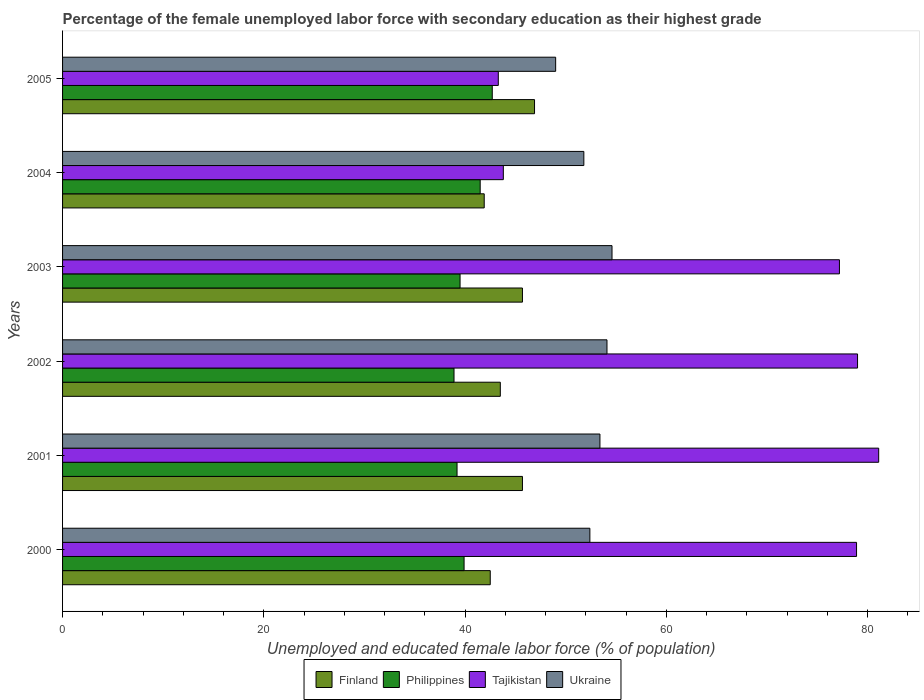How many groups of bars are there?
Provide a short and direct response. 6. Are the number of bars on each tick of the Y-axis equal?
Provide a short and direct response. Yes. How many bars are there on the 2nd tick from the top?
Keep it short and to the point. 4. In how many cases, is the number of bars for a given year not equal to the number of legend labels?
Your response must be concise. 0. What is the percentage of the unemployed female labor force with secondary education in Ukraine in 2003?
Ensure brevity in your answer.  54.6. Across all years, what is the maximum percentage of the unemployed female labor force with secondary education in Ukraine?
Offer a very short reply. 54.6. Across all years, what is the minimum percentage of the unemployed female labor force with secondary education in Finland?
Provide a short and direct response. 41.9. What is the total percentage of the unemployed female labor force with secondary education in Finland in the graph?
Your response must be concise. 266.2. What is the difference between the percentage of the unemployed female labor force with secondary education in Finland in 2002 and that in 2005?
Offer a terse response. -3.4. What is the difference between the percentage of the unemployed female labor force with secondary education in Tajikistan in 2000 and the percentage of the unemployed female labor force with secondary education in Philippines in 2003?
Offer a terse response. 39.4. What is the average percentage of the unemployed female labor force with secondary education in Finland per year?
Offer a terse response. 44.37. In the year 2004, what is the difference between the percentage of the unemployed female labor force with secondary education in Finland and percentage of the unemployed female labor force with secondary education in Philippines?
Your answer should be compact. 0.4. In how many years, is the percentage of the unemployed female labor force with secondary education in Ukraine greater than 12 %?
Give a very brief answer. 6. What is the ratio of the percentage of the unemployed female labor force with secondary education in Ukraine in 2003 to that in 2005?
Ensure brevity in your answer.  1.11. What is the difference between the highest and the second highest percentage of the unemployed female labor force with secondary education in Finland?
Give a very brief answer. 1.2. What is the difference between the highest and the lowest percentage of the unemployed female labor force with secondary education in Finland?
Offer a very short reply. 5. What does the 3rd bar from the top in 2000 represents?
Your answer should be compact. Philippines. How many bars are there?
Your response must be concise. 24. How many years are there in the graph?
Offer a terse response. 6. Are the values on the major ticks of X-axis written in scientific E-notation?
Offer a terse response. No. Does the graph contain grids?
Make the answer very short. No. Where does the legend appear in the graph?
Offer a terse response. Bottom center. How many legend labels are there?
Your answer should be compact. 4. How are the legend labels stacked?
Give a very brief answer. Horizontal. What is the title of the graph?
Provide a succinct answer. Percentage of the female unemployed labor force with secondary education as their highest grade. Does "Serbia" appear as one of the legend labels in the graph?
Offer a very short reply. No. What is the label or title of the X-axis?
Make the answer very short. Unemployed and educated female labor force (% of population). What is the label or title of the Y-axis?
Your answer should be compact. Years. What is the Unemployed and educated female labor force (% of population) of Finland in 2000?
Keep it short and to the point. 42.5. What is the Unemployed and educated female labor force (% of population) in Philippines in 2000?
Your answer should be very brief. 39.9. What is the Unemployed and educated female labor force (% of population) in Tajikistan in 2000?
Offer a terse response. 78.9. What is the Unemployed and educated female labor force (% of population) of Ukraine in 2000?
Make the answer very short. 52.4. What is the Unemployed and educated female labor force (% of population) in Finland in 2001?
Keep it short and to the point. 45.7. What is the Unemployed and educated female labor force (% of population) of Philippines in 2001?
Provide a succinct answer. 39.2. What is the Unemployed and educated female labor force (% of population) of Tajikistan in 2001?
Your answer should be very brief. 81.1. What is the Unemployed and educated female labor force (% of population) of Ukraine in 2001?
Provide a short and direct response. 53.4. What is the Unemployed and educated female labor force (% of population) in Finland in 2002?
Provide a succinct answer. 43.5. What is the Unemployed and educated female labor force (% of population) of Philippines in 2002?
Provide a succinct answer. 38.9. What is the Unemployed and educated female labor force (% of population) of Tajikistan in 2002?
Make the answer very short. 79. What is the Unemployed and educated female labor force (% of population) of Ukraine in 2002?
Offer a very short reply. 54.1. What is the Unemployed and educated female labor force (% of population) in Finland in 2003?
Your response must be concise. 45.7. What is the Unemployed and educated female labor force (% of population) of Philippines in 2003?
Offer a very short reply. 39.5. What is the Unemployed and educated female labor force (% of population) of Tajikistan in 2003?
Give a very brief answer. 77.2. What is the Unemployed and educated female labor force (% of population) of Ukraine in 2003?
Make the answer very short. 54.6. What is the Unemployed and educated female labor force (% of population) in Finland in 2004?
Your response must be concise. 41.9. What is the Unemployed and educated female labor force (% of population) in Philippines in 2004?
Your answer should be compact. 41.5. What is the Unemployed and educated female labor force (% of population) in Tajikistan in 2004?
Keep it short and to the point. 43.8. What is the Unemployed and educated female labor force (% of population) of Ukraine in 2004?
Ensure brevity in your answer.  51.8. What is the Unemployed and educated female labor force (% of population) of Finland in 2005?
Offer a very short reply. 46.9. What is the Unemployed and educated female labor force (% of population) of Philippines in 2005?
Provide a short and direct response. 42.7. What is the Unemployed and educated female labor force (% of population) of Tajikistan in 2005?
Your answer should be compact. 43.3. What is the Unemployed and educated female labor force (% of population) in Ukraine in 2005?
Your answer should be compact. 49. Across all years, what is the maximum Unemployed and educated female labor force (% of population) in Finland?
Your response must be concise. 46.9. Across all years, what is the maximum Unemployed and educated female labor force (% of population) of Philippines?
Offer a terse response. 42.7. Across all years, what is the maximum Unemployed and educated female labor force (% of population) in Tajikistan?
Give a very brief answer. 81.1. Across all years, what is the maximum Unemployed and educated female labor force (% of population) in Ukraine?
Provide a succinct answer. 54.6. Across all years, what is the minimum Unemployed and educated female labor force (% of population) of Finland?
Your answer should be very brief. 41.9. Across all years, what is the minimum Unemployed and educated female labor force (% of population) of Philippines?
Provide a short and direct response. 38.9. Across all years, what is the minimum Unemployed and educated female labor force (% of population) in Tajikistan?
Offer a terse response. 43.3. What is the total Unemployed and educated female labor force (% of population) of Finland in the graph?
Keep it short and to the point. 266.2. What is the total Unemployed and educated female labor force (% of population) in Philippines in the graph?
Offer a terse response. 241.7. What is the total Unemployed and educated female labor force (% of population) in Tajikistan in the graph?
Ensure brevity in your answer.  403.3. What is the total Unemployed and educated female labor force (% of population) in Ukraine in the graph?
Your answer should be compact. 315.3. What is the difference between the Unemployed and educated female labor force (% of population) in Finland in 2000 and that in 2001?
Your answer should be compact. -3.2. What is the difference between the Unemployed and educated female labor force (% of population) in Tajikistan in 2000 and that in 2001?
Offer a very short reply. -2.2. What is the difference between the Unemployed and educated female labor force (% of population) of Ukraine in 2000 and that in 2001?
Make the answer very short. -1. What is the difference between the Unemployed and educated female labor force (% of population) in Finland in 2000 and that in 2002?
Offer a very short reply. -1. What is the difference between the Unemployed and educated female labor force (% of population) of Tajikistan in 2000 and that in 2003?
Make the answer very short. 1.7. What is the difference between the Unemployed and educated female labor force (% of population) of Ukraine in 2000 and that in 2003?
Keep it short and to the point. -2.2. What is the difference between the Unemployed and educated female labor force (% of population) of Tajikistan in 2000 and that in 2004?
Make the answer very short. 35.1. What is the difference between the Unemployed and educated female labor force (% of population) in Finland in 2000 and that in 2005?
Offer a terse response. -4.4. What is the difference between the Unemployed and educated female labor force (% of population) in Philippines in 2000 and that in 2005?
Ensure brevity in your answer.  -2.8. What is the difference between the Unemployed and educated female labor force (% of population) in Tajikistan in 2000 and that in 2005?
Offer a very short reply. 35.6. What is the difference between the Unemployed and educated female labor force (% of population) in Ukraine in 2000 and that in 2005?
Ensure brevity in your answer.  3.4. What is the difference between the Unemployed and educated female labor force (% of population) of Tajikistan in 2001 and that in 2002?
Ensure brevity in your answer.  2.1. What is the difference between the Unemployed and educated female labor force (% of population) in Ukraine in 2001 and that in 2002?
Your answer should be very brief. -0.7. What is the difference between the Unemployed and educated female labor force (% of population) of Finland in 2001 and that in 2003?
Offer a terse response. 0. What is the difference between the Unemployed and educated female labor force (% of population) of Philippines in 2001 and that in 2003?
Your answer should be very brief. -0.3. What is the difference between the Unemployed and educated female labor force (% of population) of Ukraine in 2001 and that in 2003?
Your answer should be very brief. -1.2. What is the difference between the Unemployed and educated female labor force (% of population) in Finland in 2001 and that in 2004?
Offer a very short reply. 3.8. What is the difference between the Unemployed and educated female labor force (% of population) in Philippines in 2001 and that in 2004?
Your response must be concise. -2.3. What is the difference between the Unemployed and educated female labor force (% of population) of Tajikistan in 2001 and that in 2004?
Provide a short and direct response. 37.3. What is the difference between the Unemployed and educated female labor force (% of population) of Finland in 2001 and that in 2005?
Ensure brevity in your answer.  -1.2. What is the difference between the Unemployed and educated female labor force (% of population) in Philippines in 2001 and that in 2005?
Offer a very short reply. -3.5. What is the difference between the Unemployed and educated female labor force (% of population) of Tajikistan in 2001 and that in 2005?
Your answer should be very brief. 37.8. What is the difference between the Unemployed and educated female labor force (% of population) of Ukraine in 2001 and that in 2005?
Ensure brevity in your answer.  4.4. What is the difference between the Unemployed and educated female labor force (% of population) of Philippines in 2002 and that in 2003?
Your answer should be very brief. -0.6. What is the difference between the Unemployed and educated female labor force (% of population) in Ukraine in 2002 and that in 2003?
Make the answer very short. -0.5. What is the difference between the Unemployed and educated female labor force (% of population) in Finland in 2002 and that in 2004?
Make the answer very short. 1.6. What is the difference between the Unemployed and educated female labor force (% of population) in Tajikistan in 2002 and that in 2004?
Ensure brevity in your answer.  35.2. What is the difference between the Unemployed and educated female labor force (% of population) of Philippines in 2002 and that in 2005?
Offer a very short reply. -3.8. What is the difference between the Unemployed and educated female labor force (% of population) of Tajikistan in 2002 and that in 2005?
Provide a succinct answer. 35.7. What is the difference between the Unemployed and educated female labor force (% of population) in Ukraine in 2002 and that in 2005?
Provide a succinct answer. 5.1. What is the difference between the Unemployed and educated female labor force (% of population) in Finland in 2003 and that in 2004?
Your answer should be compact. 3.8. What is the difference between the Unemployed and educated female labor force (% of population) of Tajikistan in 2003 and that in 2004?
Ensure brevity in your answer.  33.4. What is the difference between the Unemployed and educated female labor force (% of population) of Philippines in 2003 and that in 2005?
Offer a very short reply. -3.2. What is the difference between the Unemployed and educated female labor force (% of population) of Tajikistan in 2003 and that in 2005?
Provide a short and direct response. 33.9. What is the difference between the Unemployed and educated female labor force (% of population) of Philippines in 2004 and that in 2005?
Your answer should be very brief. -1.2. What is the difference between the Unemployed and educated female labor force (% of population) of Tajikistan in 2004 and that in 2005?
Offer a very short reply. 0.5. What is the difference between the Unemployed and educated female labor force (% of population) of Finland in 2000 and the Unemployed and educated female labor force (% of population) of Philippines in 2001?
Make the answer very short. 3.3. What is the difference between the Unemployed and educated female labor force (% of population) of Finland in 2000 and the Unemployed and educated female labor force (% of population) of Tajikistan in 2001?
Give a very brief answer. -38.6. What is the difference between the Unemployed and educated female labor force (% of population) of Finland in 2000 and the Unemployed and educated female labor force (% of population) of Ukraine in 2001?
Your answer should be very brief. -10.9. What is the difference between the Unemployed and educated female labor force (% of population) of Philippines in 2000 and the Unemployed and educated female labor force (% of population) of Tajikistan in 2001?
Give a very brief answer. -41.2. What is the difference between the Unemployed and educated female labor force (% of population) of Finland in 2000 and the Unemployed and educated female labor force (% of population) of Tajikistan in 2002?
Offer a terse response. -36.5. What is the difference between the Unemployed and educated female labor force (% of population) of Finland in 2000 and the Unemployed and educated female labor force (% of population) of Ukraine in 2002?
Your response must be concise. -11.6. What is the difference between the Unemployed and educated female labor force (% of population) in Philippines in 2000 and the Unemployed and educated female labor force (% of population) in Tajikistan in 2002?
Your answer should be very brief. -39.1. What is the difference between the Unemployed and educated female labor force (% of population) of Philippines in 2000 and the Unemployed and educated female labor force (% of population) of Ukraine in 2002?
Offer a very short reply. -14.2. What is the difference between the Unemployed and educated female labor force (% of population) in Tajikistan in 2000 and the Unemployed and educated female labor force (% of population) in Ukraine in 2002?
Your answer should be compact. 24.8. What is the difference between the Unemployed and educated female labor force (% of population) in Finland in 2000 and the Unemployed and educated female labor force (% of population) in Tajikistan in 2003?
Provide a short and direct response. -34.7. What is the difference between the Unemployed and educated female labor force (% of population) in Philippines in 2000 and the Unemployed and educated female labor force (% of population) in Tajikistan in 2003?
Offer a terse response. -37.3. What is the difference between the Unemployed and educated female labor force (% of population) of Philippines in 2000 and the Unemployed and educated female labor force (% of population) of Ukraine in 2003?
Make the answer very short. -14.7. What is the difference between the Unemployed and educated female labor force (% of population) of Tajikistan in 2000 and the Unemployed and educated female labor force (% of population) of Ukraine in 2003?
Offer a very short reply. 24.3. What is the difference between the Unemployed and educated female labor force (% of population) in Finland in 2000 and the Unemployed and educated female labor force (% of population) in Philippines in 2004?
Keep it short and to the point. 1. What is the difference between the Unemployed and educated female labor force (% of population) in Finland in 2000 and the Unemployed and educated female labor force (% of population) in Tajikistan in 2004?
Keep it short and to the point. -1.3. What is the difference between the Unemployed and educated female labor force (% of population) of Philippines in 2000 and the Unemployed and educated female labor force (% of population) of Ukraine in 2004?
Offer a terse response. -11.9. What is the difference between the Unemployed and educated female labor force (% of population) of Tajikistan in 2000 and the Unemployed and educated female labor force (% of population) of Ukraine in 2004?
Your answer should be compact. 27.1. What is the difference between the Unemployed and educated female labor force (% of population) in Philippines in 2000 and the Unemployed and educated female labor force (% of population) in Tajikistan in 2005?
Ensure brevity in your answer.  -3.4. What is the difference between the Unemployed and educated female labor force (% of population) in Tajikistan in 2000 and the Unemployed and educated female labor force (% of population) in Ukraine in 2005?
Ensure brevity in your answer.  29.9. What is the difference between the Unemployed and educated female labor force (% of population) of Finland in 2001 and the Unemployed and educated female labor force (% of population) of Tajikistan in 2002?
Your response must be concise. -33.3. What is the difference between the Unemployed and educated female labor force (% of population) of Philippines in 2001 and the Unemployed and educated female labor force (% of population) of Tajikistan in 2002?
Keep it short and to the point. -39.8. What is the difference between the Unemployed and educated female labor force (% of population) in Philippines in 2001 and the Unemployed and educated female labor force (% of population) in Ukraine in 2002?
Give a very brief answer. -14.9. What is the difference between the Unemployed and educated female labor force (% of population) of Tajikistan in 2001 and the Unemployed and educated female labor force (% of population) of Ukraine in 2002?
Provide a succinct answer. 27. What is the difference between the Unemployed and educated female labor force (% of population) of Finland in 2001 and the Unemployed and educated female labor force (% of population) of Tajikistan in 2003?
Ensure brevity in your answer.  -31.5. What is the difference between the Unemployed and educated female labor force (% of population) of Philippines in 2001 and the Unemployed and educated female labor force (% of population) of Tajikistan in 2003?
Your answer should be compact. -38. What is the difference between the Unemployed and educated female labor force (% of population) in Philippines in 2001 and the Unemployed and educated female labor force (% of population) in Ukraine in 2003?
Give a very brief answer. -15.4. What is the difference between the Unemployed and educated female labor force (% of population) in Tajikistan in 2001 and the Unemployed and educated female labor force (% of population) in Ukraine in 2003?
Give a very brief answer. 26.5. What is the difference between the Unemployed and educated female labor force (% of population) in Finland in 2001 and the Unemployed and educated female labor force (% of population) in Tajikistan in 2004?
Give a very brief answer. 1.9. What is the difference between the Unemployed and educated female labor force (% of population) of Tajikistan in 2001 and the Unemployed and educated female labor force (% of population) of Ukraine in 2004?
Offer a terse response. 29.3. What is the difference between the Unemployed and educated female labor force (% of population) in Finland in 2001 and the Unemployed and educated female labor force (% of population) in Tajikistan in 2005?
Make the answer very short. 2.4. What is the difference between the Unemployed and educated female labor force (% of population) of Philippines in 2001 and the Unemployed and educated female labor force (% of population) of Tajikistan in 2005?
Offer a terse response. -4.1. What is the difference between the Unemployed and educated female labor force (% of population) of Tajikistan in 2001 and the Unemployed and educated female labor force (% of population) of Ukraine in 2005?
Offer a terse response. 32.1. What is the difference between the Unemployed and educated female labor force (% of population) of Finland in 2002 and the Unemployed and educated female labor force (% of population) of Philippines in 2003?
Your answer should be compact. 4. What is the difference between the Unemployed and educated female labor force (% of population) of Finland in 2002 and the Unemployed and educated female labor force (% of population) of Tajikistan in 2003?
Provide a short and direct response. -33.7. What is the difference between the Unemployed and educated female labor force (% of population) in Philippines in 2002 and the Unemployed and educated female labor force (% of population) in Tajikistan in 2003?
Your response must be concise. -38.3. What is the difference between the Unemployed and educated female labor force (% of population) of Philippines in 2002 and the Unemployed and educated female labor force (% of population) of Ukraine in 2003?
Offer a terse response. -15.7. What is the difference between the Unemployed and educated female labor force (% of population) in Tajikistan in 2002 and the Unemployed and educated female labor force (% of population) in Ukraine in 2003?
Provide a succinct answer. 24.4. What is the difference between the Unemployed and educated female labor force (% of population) of Finland in 2002 and the Unemployed and educated female labor force (% of population) of Philippines in 2004?
Your response must be concise. 2. What is the difference between the Unemployed and educated female labor force (% of population) in Finland in 2002 and the Unemployed and educated female labor force (% of population) in Tajikistan in 2004?
Your response must be concise. -0.3. What is the difference between the Unemployed and educated female labor force (% of population) in Finland in 2002 and the Unemployed and educated female labor force (% of population) in Ukraine in 2004?
Offer a very short reply. -8.3. What is the difference between the Unemployed and educated female labor force (% of population) of Philippines in 2002 and the Unemployed and educated female labor force (% of population) of Ukraine in 2004?
Your response must be concise. -12.9. What is the difference between the Unemployed and educated female labor force (% of population) in Tajikistan in 2002 and the Unemployed and educated female labor force (% of population) in Ukraine in 2004?
Provide a succinct answer. 27.2. What is the difference between the Unemployed and educated female labor force (% of population) in Finland in 2002 and the Unemployed and educated female labor force (% of population) in Philippines in 2005?
Provide a short and direct response. 0.8. What is the difference between the Unemployed and educated female labor force (% of population) of Finland in 2002 and the Unemployed and educated female labor force (% of population) of Tajikistan in 2005?
Provide a succinct answer. 0.2. What is the difference between the Unemployed and educated female labor force (% of population) in Finland in 2002 and the Unemployed and educated female labor force (% of population) in Ukraine in 2005?
Make the answer very short. -5.5. What is the difference between the Unemployed and educated female labor force (% of population) of Philippines in 2002 and the Unemployed and educated female labor force (% of population) of Ukraine in 2005?
Your answer should be compact. -10.1. What is the difference between the Unemployed and educated female labor force (% of population) of Philippines in 2003 and the Unemployed and educated female labor force (% of population) of Tajikistan in 2004?
Your response must be concise. -4.3. What is the difference between the Unemployed and educated female labor force (% of population) in Philippines in 2003 and the Unemployed and educated female labor force (% of population) in Ukraine in 2004?
Ensure brevity in your answer.  -12.3. What is the difference between the Unemployed and educated female labor force (% of population) in Tajikistan in 2003 and the Unemployed and educated female labor force (% of population) in Ukraine in 2004?
Your answer should be compact. 25.4. What is the difference between the Unemployed and educated female labor force (% of population) in Finland in 2003 and the Unemployed and educated female labor force (% of population) in Philippines in 2005?
Provide a short and direct response. 3. What is the difference between the Unemployed and educated female labor force (% of population) in Philippines in 2003 and the Unemployed and educated female labor force (% of population) in Tajikistan in 2005?
Provide a short and direct response. -3.8. What is the difference between the Unemployed and educated female labor force (% of population) in Philippines in 2003 and the Unemployed and educated female labor force (% of population) in Ukraine in 2005?
Keep it short and to the point. -9.5. What is the difference between the Unemployed and educated female labor force (% of population) of Tajikistan in 2003 and the Unemployed and educated female labor force (% of population) of Ukraine in 2005?
Offer a very short reply. 28.2. What is the difference between the Unemployed and educated female labor force (% of population) in Philippines in 2004 and the Unemployed and educated female labor force (% of population) in Tajikistan in 2005?
Ensure brevity in your answer.  -1.8. What is the average Unemployed and educated female labor force (% of population) of Finland per year?
Your answer should be compact. 44.37. What is the average Unemployed and educated female labor force (% of population) of Philippines per year?
Make the answer very short. 40.28. What is the average Unemployed and educated female labor force (% of population) of Tajikistan per year?
Your answer should be very brief. 67.22. What is the average Unemployed and educated female labor force (% of population) in Ukraine per year?
Your answer should be very brief. 52.55. In the year 2000, what is the difference between the Unemployed and educated female labor force (% of population) in Finland and Unemployed and educated female labor force (% of population) in Tajikistan?
Give a very brief answer. -36.4. In the year 2000, what is the difference between the Unemployed and educated female labor force (% of population) of Finland and Unemployed and educated female labor force (% of population) of Ukraine?
Offer a very short reply. -9.9. In the year 2000, what is the difference between the Unemployed and educated female labor force (% of population) in Philippines and Unemployed and educated female labor force (% of population) in Tajikistan?
Ensure brevity in your answer.  -39. In the year 2001, what is the difference between the Unemployed and educated female labor force (% of population) of Finland and Unemployed and educated female labor force (% of population) of Philippines?
Keep it short and to the point. 6.5. In the year 2001, what is the difference between the Unemployed and educated female labor force (% of population) in Finland and Unemployed and educated female labor force (% of population) in Tajikistan?
Offer a terse response. -35.4. In the year 2001, what is the difference between the Unemployed and educated female labor force (% of population) of Philippines and Unemployed and educated female labor force (% of population) of Tajikistan?
Make the answer very short. -41.9. In the year 2001, what is the difference between the Unemployed and educated female labor force (% of population) of Philippines and Unemployed and educated female labor force (% of population) of Ukraine?
Ensure brevity in your answer.  -14.2. In the year 2001, what is the difference between the Unemployed and educated female labor force (% of population) in Tajikistan and Unemployed and educated female labor force (% of population) in Ukraine?
Keep it short and to the point. 27.7. In the year 2002, what is the difference between the Unemployed and educated female labor force (% of population) in Finland and Unemployed and educated female labor force (% of population) in Tajikistan?
Your answer should be compact. -35.5. In the year 2002, what is the difference between the Unemployed and educated female labor force (% of population) in Philippines and Unemployed and educated female labor force (% of population) in Tajikistan?
Keep it short and to the point. -40.1. In the year 2002, what is the difference between the Unemployed and educated female labor force (% of population) in Philippines and Unemployed and educated female labor force (% of population) in Ukraine?
Ensure brevity in your answer.  -15.2. In the year 2002, what is the difference between the Unemployed and educated female labor force (% of population) of Tajikistan and Unemployed and educated female labor force (% of population) of Ukraine?
Your answer should be compact. 24.9. In the year 2003, what is the difference between the Unemployed and educated female labor force (% of population) in Finland and Unemployed and educated female labor force (% of population) in Tajikistan?
Your response must be concise. -31.5. In the year 2003, what is the difference between the Unemployed and educated female labor force (% of population) in Finland and Unemployed and educated female labor force (% of population) in Ukraine?
Your answer should be very brief. -8.9. In the year 2003, what is the difference between the Unemployed and educated female labor force (% of population) of Philippines and Unemployed and educated female labor force (% of population) of Tajikistan?
Ensure brevity in your answer.  -37.7. In the year 2003, what is the difference between the Unemployed and educated female labor force (% of population) of Philippines and Unemployed and educated female labor force (% of population) of Ukraine?
Ensure brevity in your answer.  -15.1. In the year 2003, what is the difference between the Unemployed and educated female labor force (% of population) of Tajikistan and Unemployed and educated female labor force (% of population) of Ukraine?
Give a very brief answer. 22.6. In the year 2004, what is the difference between the Unemployed and educated female labor force (% of population) of Finland and Unemployed and educated female labor force (% of population) of Philippines?
Your answer should be very brief. 0.4. In the year 2004, what is the difference between the Unemployed and educated female labor force (% of population) in Finland and Unemployed and educated female labor force (% of population) in Tajikistan?
Offer a very short reply. -1.9. In the year 2004, what is the difference between the Unemployed and educated female labor force (% of population) of Philippines and Unemployed and educated female labor force (% of population) of Tajikistan?
Your response must be concise. -2.3. In the year 2004, what is the difference between the Unemployed and educated female labor force (% of population) in Philippines and Unemployed and educated female labor force (% of population) in Ukraine?
Ensure brevity in your answer.  -10.3. In the year 2004, what is the difference between the Unemployed and educated female labor force (% of population) of Tajikistan and Unemployed and educated female labor force (% of population) of Ukraine?
Ensure brevity in your answer.  -8. In the year 2005, what is the difference between the Unemployed and educated female labor force (% of population) in Finland and Unemployed and educated female labor force (% of population) in Philippines?
Give a very brief answer. 4.2. What is the ratio of the Unemployed and educated female labor force (% of population) in Finland in 2000 to that in 2001?
Your answer should be very brief. 0.93. What is the ratio of the Unemployed and educated female labor force (% of population) in Philippines in 2000 to that in 2001?
Provide a succinct answer. 1.02. What is the ratio of the Unemployed and educated female labor force (% of population) in Tajikistan in 2000 to that in 2001?
Offer a terse response. 0.97. What is the ratio of the Unemployed and educated female labor force (% of population) in Ukraine in 2000 to that in 2001?
Make the answer very short. 0.98. What is the ratio of the Unemployed and educated female labor force (% of population) in Finland in 2000 to that in 2002?
Give a very brief answer. 0.98. What is the ratio of the Unemployed and educated female labor force (% of population) in Philippines in 2000 to that in 2002?
Make the answer very short. 1.03. What is the ratio of the Unemployed and educated female labor force (% of population) of Ukraine in 2000 to that in 2002?
Your answer should be very brief. 0.97. What is the ratio of the Unemployed and educated female labor force (% of population) in Philippines in 2000 to that in 2003?
Ensure brevity in your answer.  1.01. What is the ratio of the Unemployed and educated female labor force (% of population) of Ukraine in 2000 to that in 2003?
Provide a succinct answer. 0.96. What is the ratio of the Unemployed and educated female labor force (% of population) in Finland in 2000 to that in 2004?
Give a very brief answer. 1.01. What is the ratio of the Unemployed and educated female labor force (% of population) of Philippines in 2000 to that in 2004?
Provide a succinct answer. 0.96. What is the ratio of the Unemployed and educated female labor force (% of population) in Tajikistan in 2000 to that in 2004?
Give a very brief answer. 1.8. What is the ratio of the Unemployed and educated female labor force (% of population) in Ukraine in 2000 to that in 2004?
Make the answer very short. 1.01. What is the ratio of the Unemployed and educated female labor force (% of population) in Finland in 2000 to that in 2005?
Your answer should be very brief. 0.91. What is the ratio of the Unemployed and educated female labor force (% of population) of Philippines in 2000 to that in 2005?
Provide a succinct answer. 0.93. What is the ratio of the Unemployed and educated female labor force (% of population) in Tajikistan in 2000 to that in 2005?
Keep it short and to the point. 1.82. What is the ratio of the Unemployed and educated female labor force (% of population) of Ukraine in 2000 to that in 2005?
Give a very brief answer. 1.07. What is the ratio of the Unemployed and educated female labor force (% of population) in Finland in 2001 to that in 2002?
Make the answer very short. 1.05. What is the ratio of the Unemployed and educated female labor force (% of population) of Philippines in 2001 to that in 2002?
Offer a very short reply. 1.01. What is the ratio of the Unemployed and educated female labor force (% of population) in Tajikistan in 2001 to that in 2002?
Provide a short and direct response. 1.03. What is the ratio of the Unemployed and educated female labor force (% of population) in Ukraine in 2001 to that in 2002?
Your response must be concise. 0.99. What is the ratio of the Unemployed and educated female labor force (% of population) in Philippines in 2001 to that in 2003?
Make the answer very short. 0.99. What is the ratio of the Unemployed and educated female labor force (% of population) in Tajikistan in 2001 to that in 2003?
Provide a succinct answer. 1.05. What is the ratio of the Unemployed and educated female labor force (% of population) of Ukraine in 2001 to that in 2003?
Your answer should be very brief. 0.98. What is the ratio of the Unemployed and educated female labor force (% of population) of Finland in 2001 to that in 2004?
Offer a very short reply. 1.09. What is the ratio of the Unemployed and educated female labor force (% of population) of Philippines in 2001 to that in 2004?
Provide a short and direct response. 0.94. What is the ratio of the Unemployed and educated female labor force (% of population) in Tajikistan in 2001 to that in 2004?
Offer a terse response. 1.85. What is the ratio of the Unemployed and educated female labor force (% of population) in Ukraine in 2001 to that in 2004?
Offer a very short reply. 1.03. What is the ratio of the Unemployed and educated female labor force (% of population) in Finland in 2001 to that in 2005?
Ensure brevity in your answer.  0.97. What is the ratio of the Unemployed and educated female labor force (% of population) of Philippines in 2001 to that in 2005?
Offer a terse response. 0.92. What is the ratio of the Unemployed and educated female labor force (% of population) of Tajikistan in 2001 to that in 2005?
Make the answer very short. 1.87. What is the ratio of the Unemployed and educated female labor force (% of population) of Ukraine in 2001 to that in 2005?
Keep it short and to the point. 1.09. What is the ratio of the Unemployed and educated female labor force (% of population) of Finland in 2002 to that in 2003?
Your answer should be compact. 0.95. What is the ratio of the Unemployed and educated female labor force (% of population) of Philippines in 2002 to that in 2003?
Keep it short and to the point. 0.98. What is the ratio of the Unemployed and educated female labor force (% of population) in Tajikistan in 2002 to that in 2003?
Offer a very short reply. 1.02. What is the ratio of the Unemployed and educated female labor force (% of population) of Ukraine in 2002 to that in 2003?
Offer a very short reply. 0.99. What is the ratio of the Unemployed and educated female labor force (% of population) in Finland in 2002 to that in 2004?
Offer a terse response. 1.04. What is the ratio of the Unemployed and educated female labor force (% of population) in Philippines in 2002 to that in 2004?
Provide a succinct answer. 0.94. What is the ratio of the Unemployed and educated female labor force (% of population) of Tajikistan in 2002 to that in 2004?
Keep it short and to the point. 1.8. What is the ratio of the Unemployed and educated female labor force (% of population) in Ukraine in 2002 to that in 2004?
Offer a terse response. 1.04. What is the ratio of the Unemployed and educated female labor force (% of population) of Finland in 2002 to that in 2005?
Your response must be concise. 0.93. What is the ratio of the Unemployed and educated female labor force (% of population) of Philippines in 2002 to that in 2005?
Provide a short and direct response. 0.91. What is the ratio of the Unemployed and educated female labor force (% of population) in Tajikistan in 2002 to that in 2005?
Provide a short and direct response. 1.82. What is the ratio of the Unemployed and educated female labor force (% of population) of Ukraine in 2002 to that in 2005?
Your answer should be compact. 1.1. What is the ratio of the Unemployed and educated female labor force (% of population) of Finland in 2003 to that in 2004?
Offer a very short reply. 1.09. What is the ratio of the Unemployed and educated female labor force (% of population) of Philippines in 2003 to that in 2004?
Ensure brevity in your answer.  0.95. What is the ratio of the Unemployed and educated female labor force (% of population) in Tajikistan in 2003 to that in 2004?
Give a very brief answer. 1.76. What is the ratio of the Unemployed and educated female labor force (% of population) in Ukraine in 2003 to that in 2004?
Give a very brief answer. 1.05. What is the ratio of the Unemployed and educated female labor force (% of population) in Finland in 2003 to that in 2005?
Make the answer very short. 0.97. What is the ratio of the Unemployed and educated female labor force (% of population) in Philippines in 2003 to that in 2005?
Your answer should be very brief. 0.93. What is the ratio of the Unemployed and educated female labor force (% of population) in Tajikistan in 2003 to that in 2005?
Your answer should be compact. 1.78. What is the ratio of the Unemployed and educated female labor force (% of population) of Ukraine in 2003 to that in 2005?
Offer a terse response. 1.11. What is the ratio of the Unemployed and educated female labor force (% of population) in Finland in 2004 to that in 2005?
Give a very brief answer. 0.89. What is the ratio of the Unemployed and educated female labor force (% of population) of Philippines in 2004 to that in 2005?
Give a very brief answer. 0.97. What is the ratio of the Unemployed and educated female labor force (% of population) in Tajikistan in 2004 to that in 2005?
Make the answer very short. 1.01. What is the ratio of the Unemployed and educated female labor force (% of population) in Ukraine in 2004 to that in 2005?
Offer a terse response. 1.06. What is the difference between the highest and the second highest Unemployed and educated female labor force (% of population) of Finland?
Ensure brevity in your answer.  1.2. What is the difference between the highest and the second highest Unemployed and educated female labor force (% of population) in Tajikistan?
Offer a terse response. 2.1. What is the difference between the highest and the second highest Unemployed and educated female labor force (% of population) of Ukraine?
Your answer should be compact. 0.5. What is the difference between the highest and the lowest Unemployed and educated female labor force (% of population) of Tajikistan?
Keep it short and to the point. 37.8. What is the difference between the highest and the lowest Unemployed and educated female labor force (% of population) of Ukraine?
Make the answer very short. 5.6. 